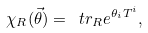Convert formula to latex. <formula><loc_0><loc_0><loc_500><loc_500>\chi _ { R } ( \vec { \theta } ) = \ t r _ { R } e ^ { \theta _ { i } T ^ { i } } ,</formula> 